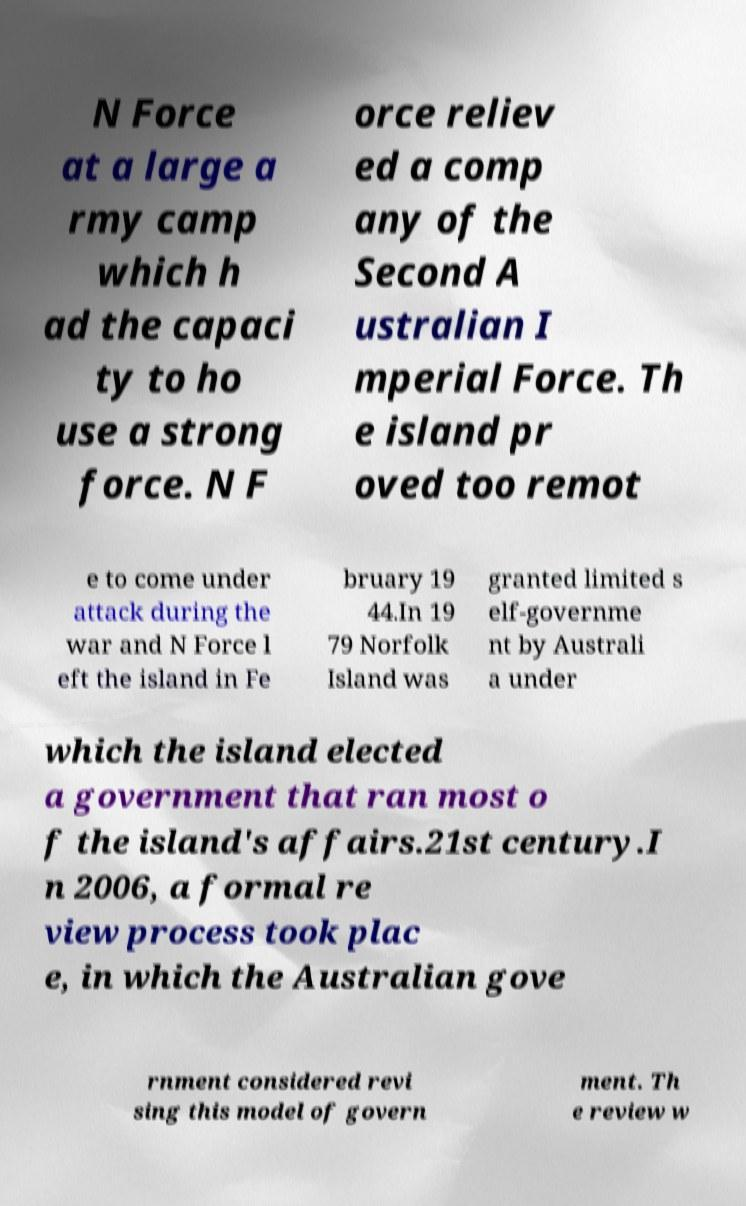Can you accurately transcribe the text from the provided image for me? N Force at a large a rmy camp which h ad the capaci ty to ho use a strong force. N F orce reliev ed a comp any of the Second A ustralian I mperial Force. Th e island pr oved too remot e to come under attack during the war and N Force l eft the island in Fe bruary 19 44.In 19 79 Norfolk Island was granted limited s elf-governme nt by Australi a under which the island elected a government that ran most o f the island's affairs.21st century.I n 2006, a formal re view process took plac e, in which the Australian gove rnment considered revi sing this model of govern ment. Th e review w 